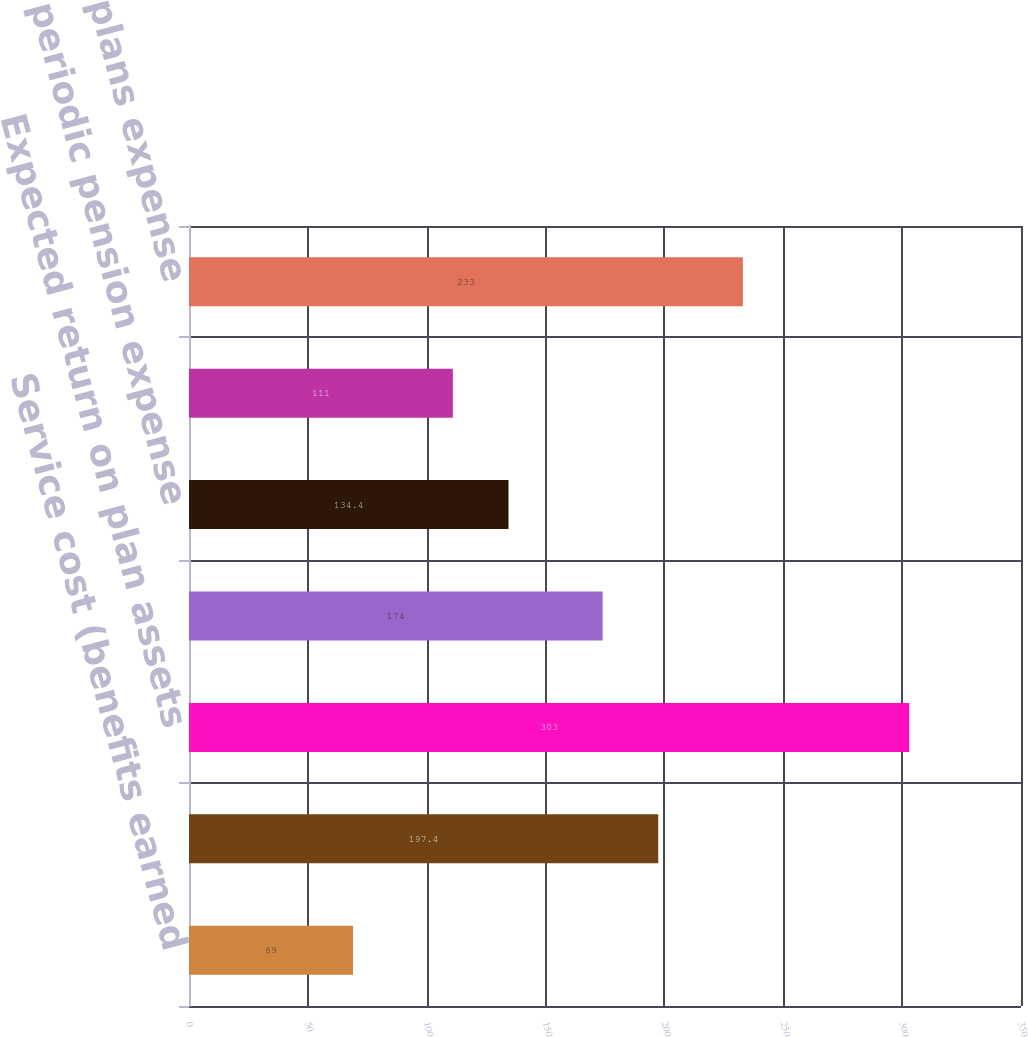<chart> <loc_0><loc_0><loc_500><loc_500><bar_chart><fcel>Service cost (benefits earned<fcel>Interest cost<fcel>Expected return on plan assets<fcel>Net amortization and other<fcel>Net periodic pension expense<fcel>Defined contribution plans<fcel>Total retirement plans expense<nl><fcel>69<fcel>197.4<fcel>303<fcel>174<fcel>134.4<fcel>111<fcel>233<nl></chart> 